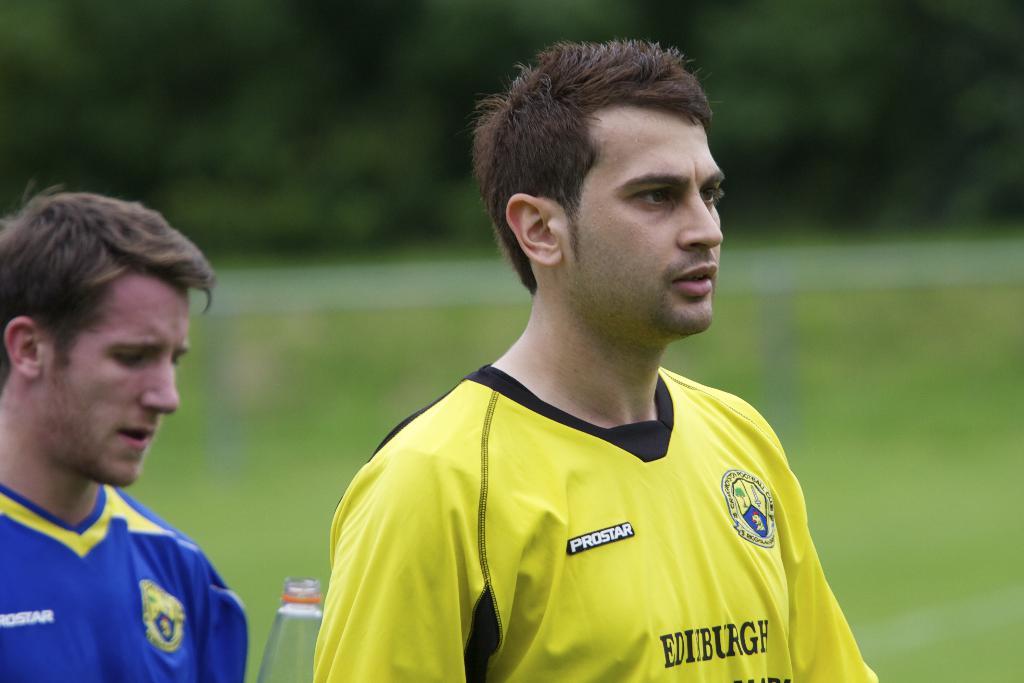What town are they playing in?
Your response must be concise. Edinburgh. 